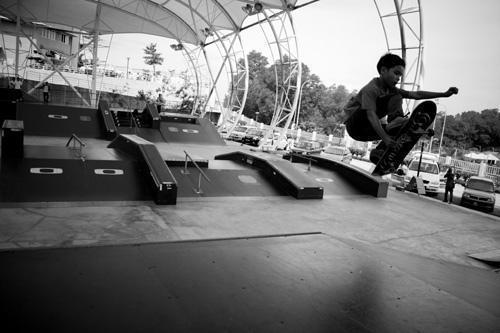How many people can you see?
Give a very brief answer. 1. 